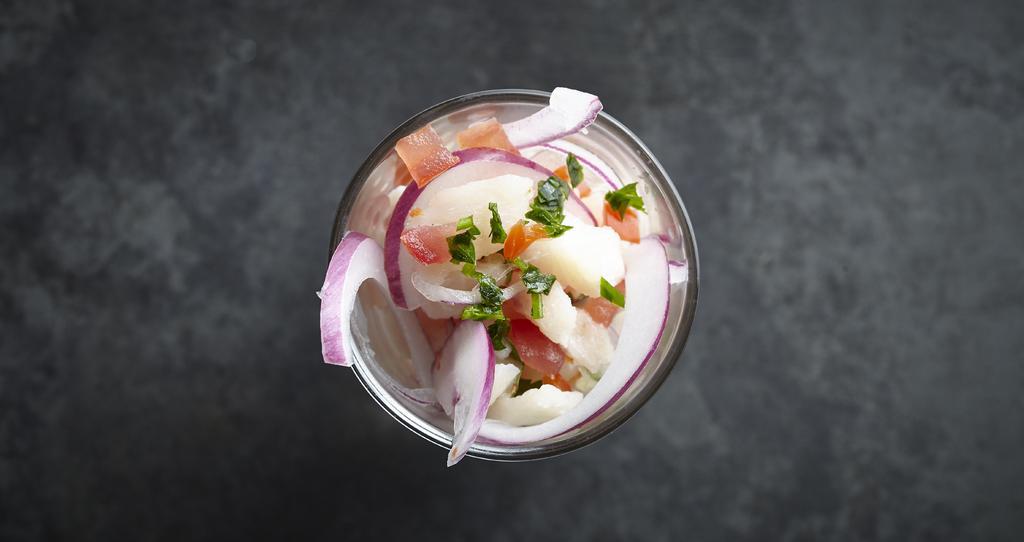How would you summarize this image in a sentence or two? In this image there is a bowl on the floor. There are vegetables in the bowl. There are sliced onions, chopped tomatoes, herbs and potatoes. 